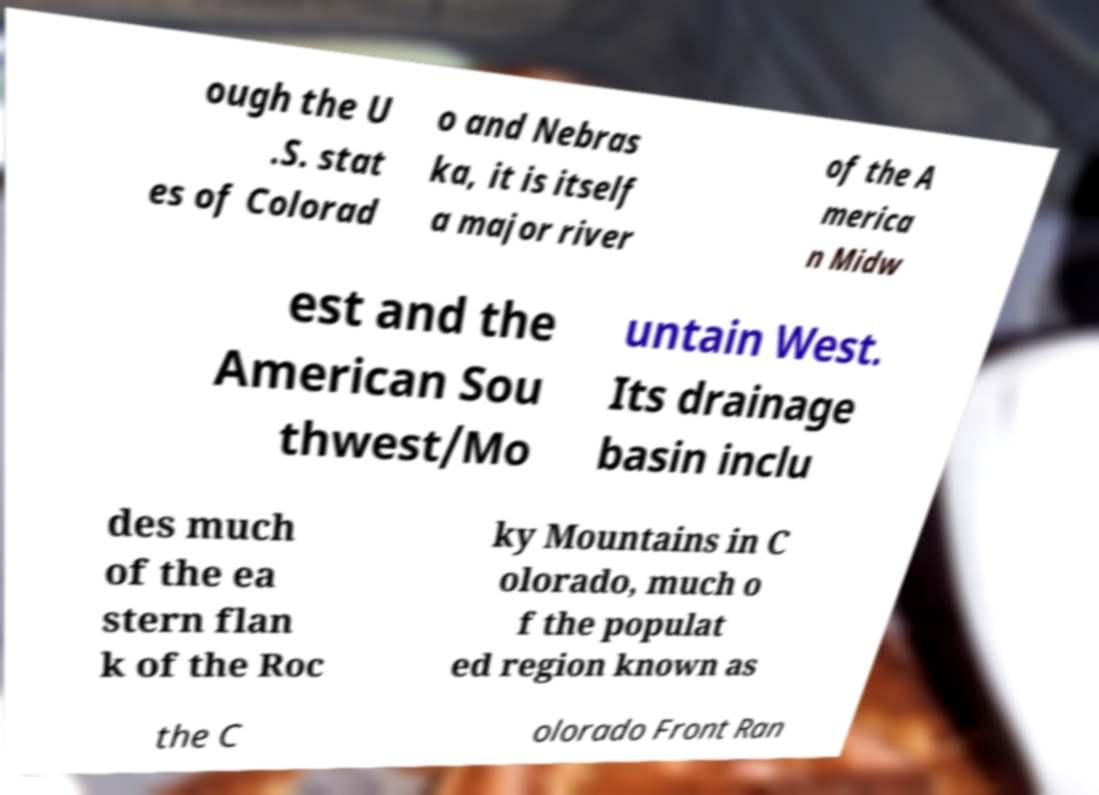There's text embedded in this image that I need extracted. Can you transcribe it verbatim? ough the U .S. stat es of Colorad o and Nebras ka, it is itself a major river of the A merica n Midw est and the American Sou thwest/Mo untain West. Its drainage basin inclu des much of the ea stern flan k of the Roc ky Mountains in C olorado, much o f the populat ed region known as the C olorado Front Ran 